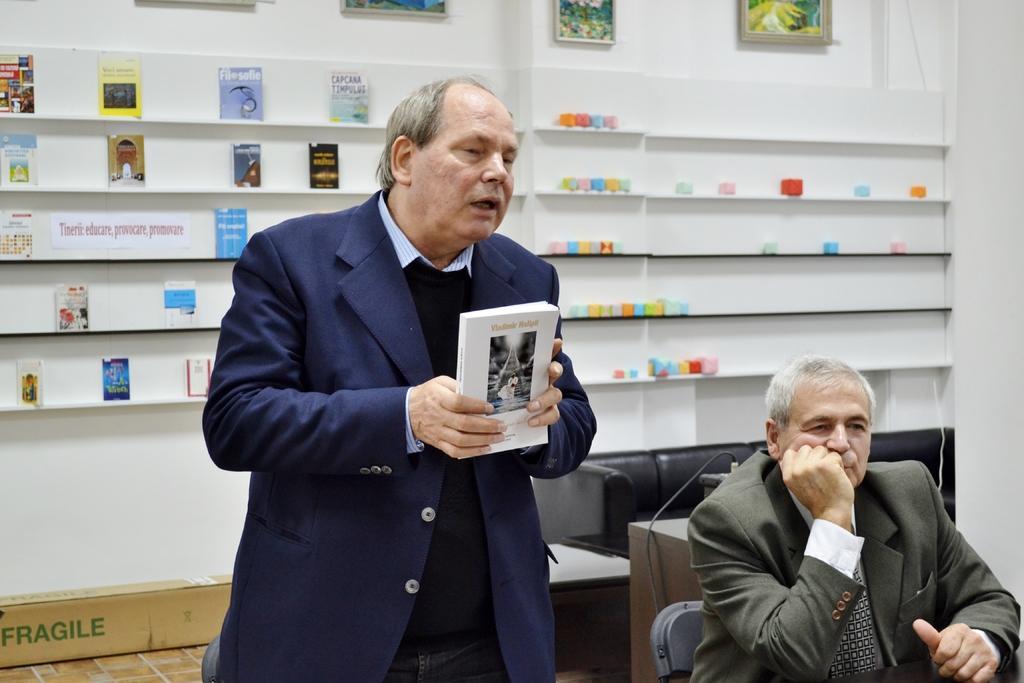In one or two sentences, can you explain what this image depicts? In this image, we can see two persons wearing clothes. There is a person at the bottom of the image holding a book with his hands. There is a wall shelf in the middle of the image contains some books and objects. There is a sofa in the bottom right of the image. There are paintings on the wall. 